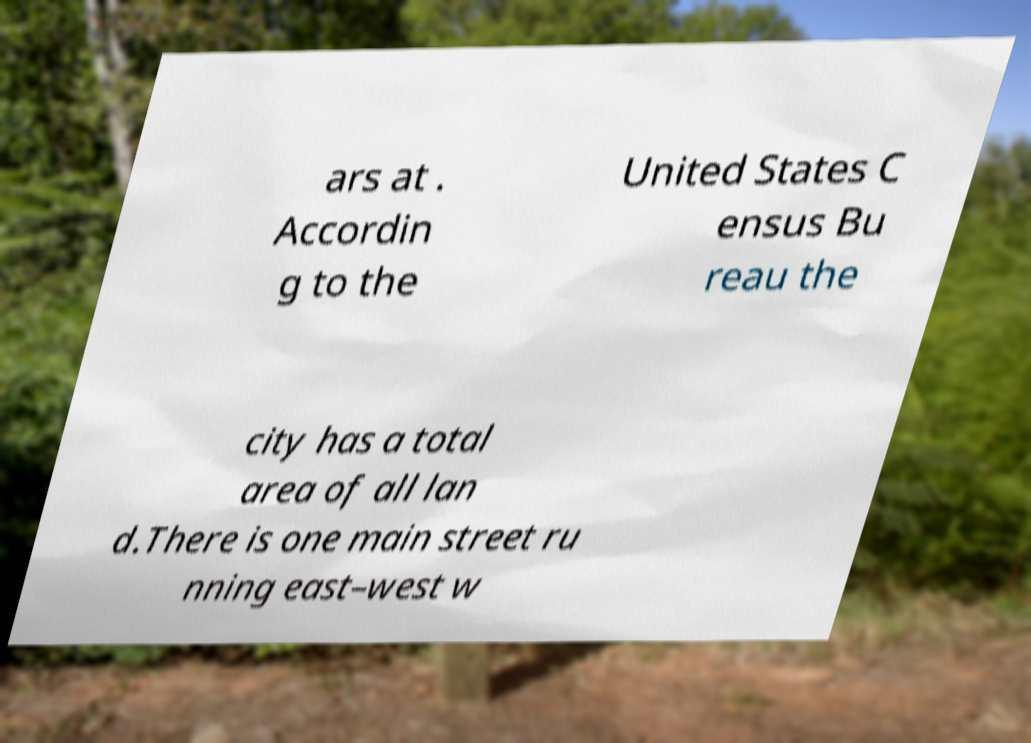Can you read and provide the text displayed in the image?This photo seems to have some interesting text. Can you extract and type it out for me? ars at . Accordin g to the United States C ensus Bu reau the city has a total area of all lan d.There is one main street ru nning east–west w 